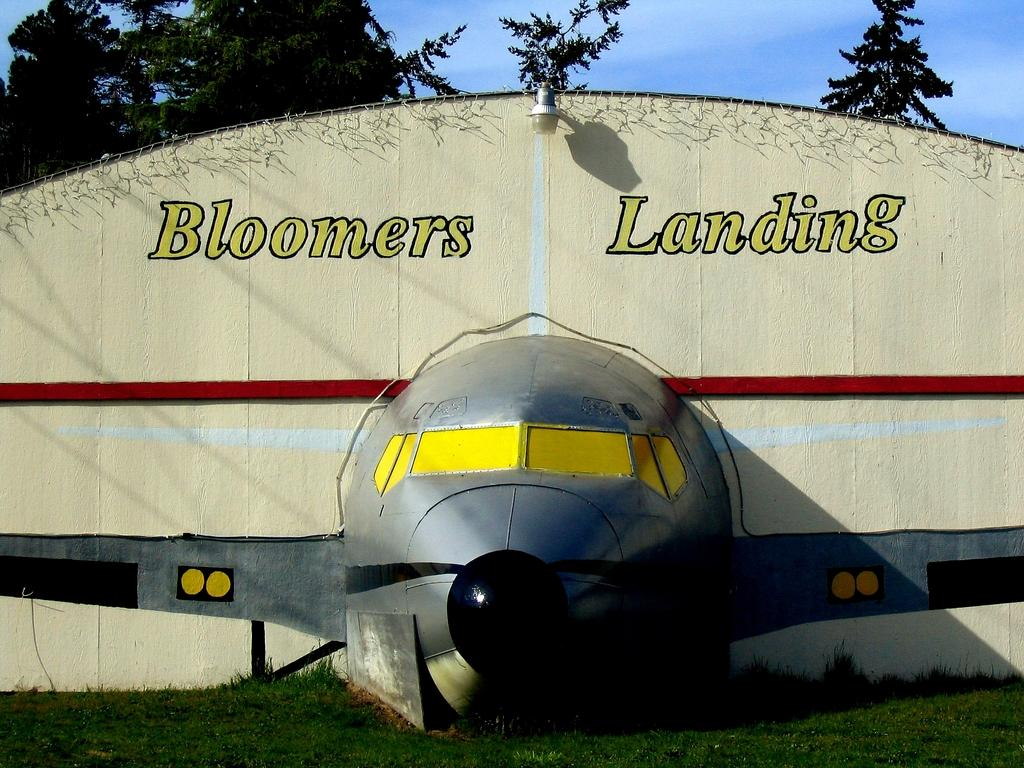<image>
Write a terse but informative summary of the picture. A display of an airplane hanger and plane is called Boomers Landing. 